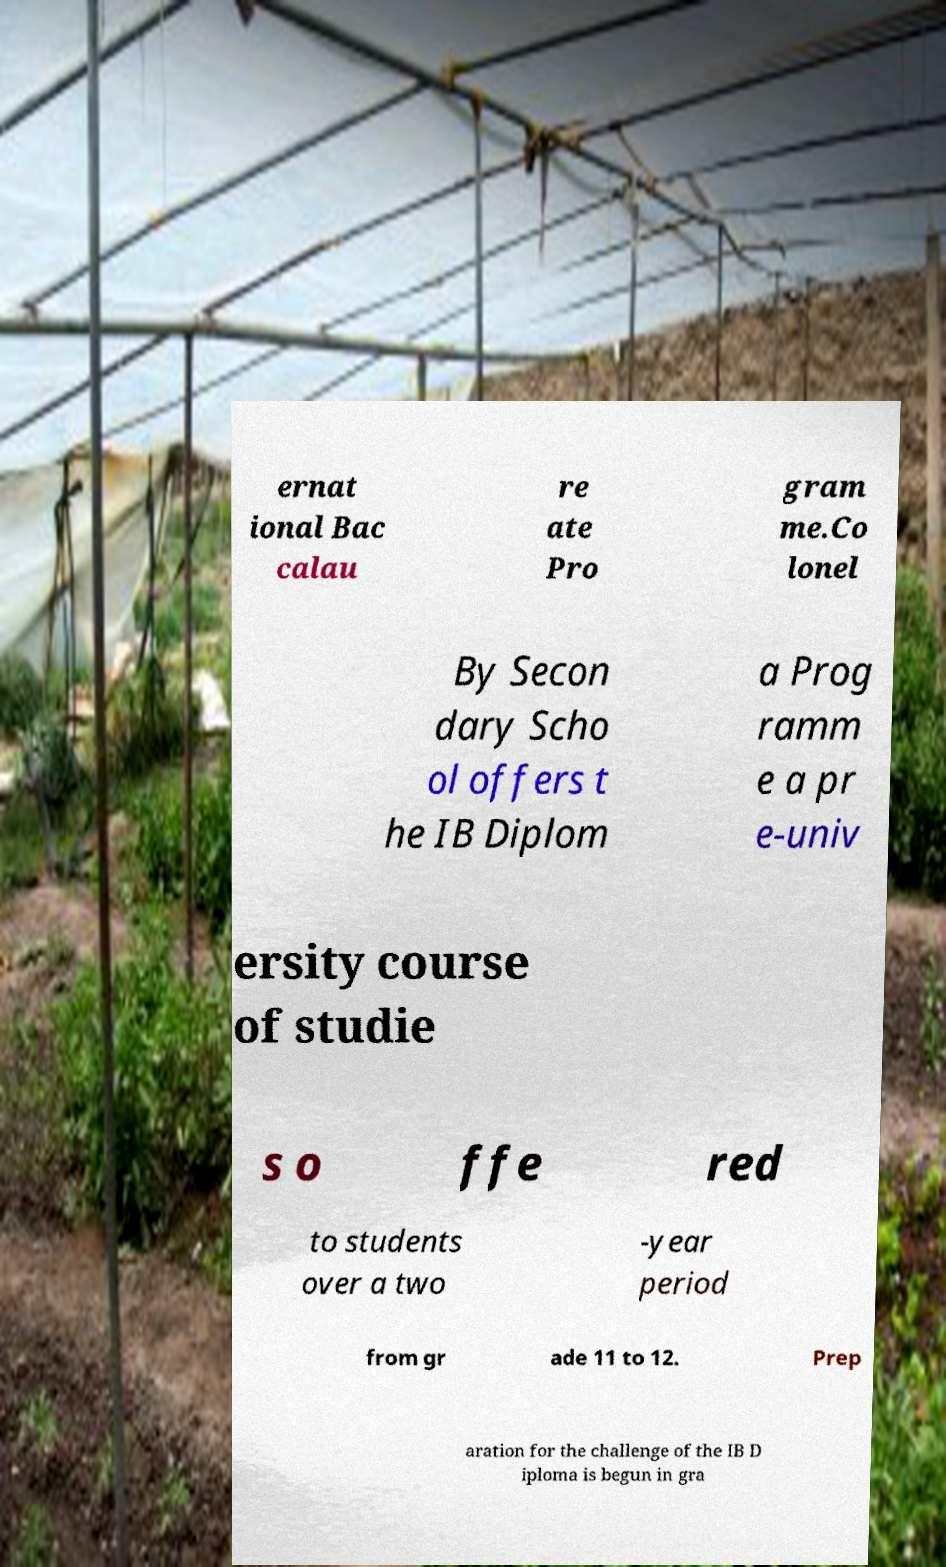There's text embedded in this image that I need extracted. Can you transcribe it verbatim? ernat ional Bac calau re ate Pro gram me.Co lonel By Secon dary Scho ol offers t he IB Diplom a Prog ramm e a pr e-univ ersity course of studie s o ffe red to students over a two -year period from gr ade 11 to 12. Prep aration for the challenge of the IB D iploma is begun in gra 